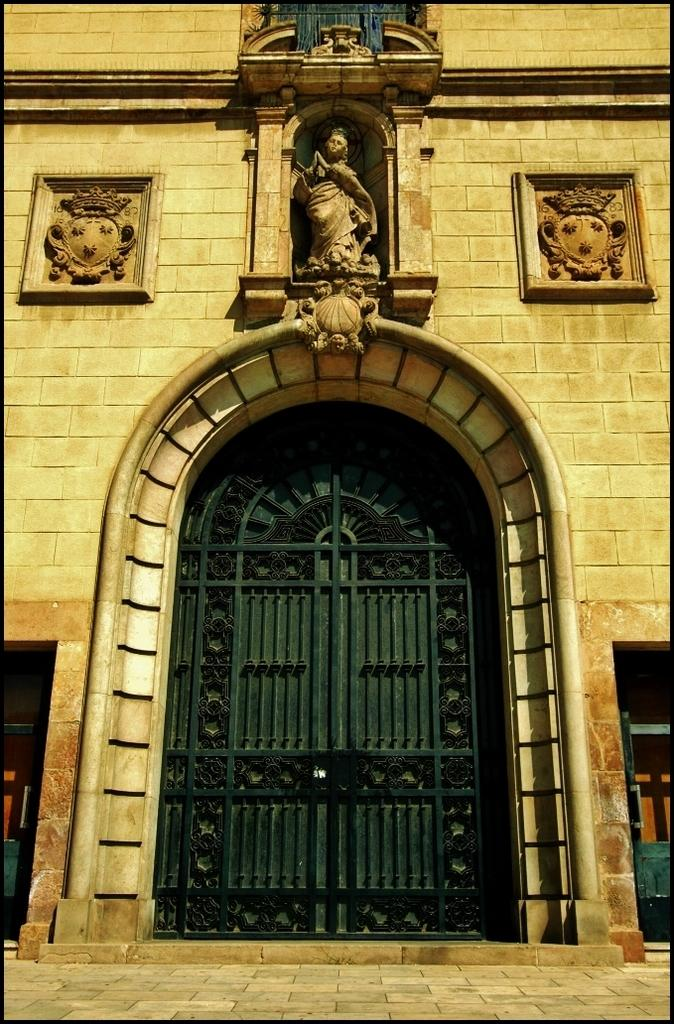What can be seen in the foreground of the image? There is a side path in the foreground of the image. What structures are visible in the background of the image? There is a gate and an arch in the background of the image. Are there any decorative elements on the buildings in the image? Yes, there are sculptures on the wall of a building in the background of the image. What type of plastic is used to create the behavior of the account in the image? There is no plastic, behavior, or account present in the image. 